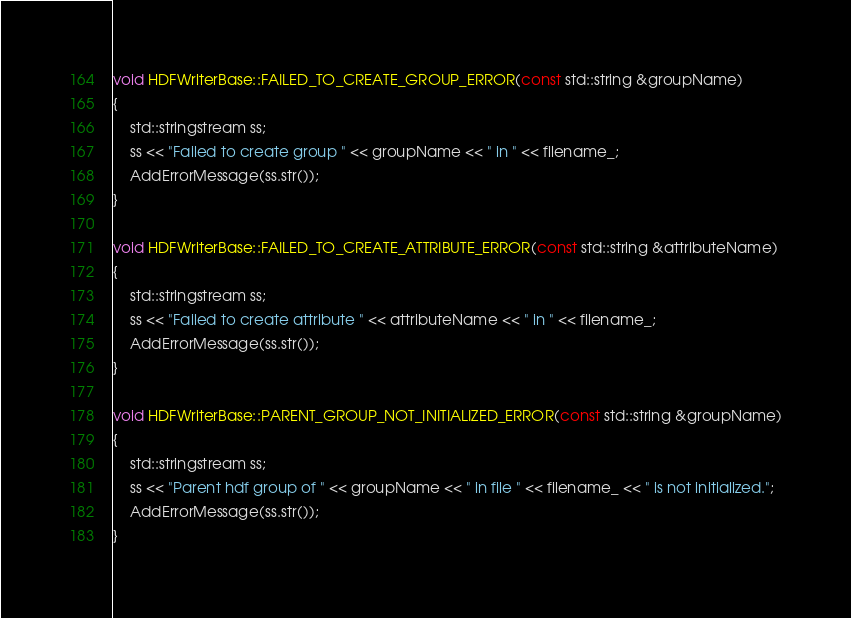Convert code to text. <code><loc_0><loc_0><loc_500><loc_500><_C++_>
void HDFWriterBase::FAILED_TO_CREATE_GROUP_ERROR(const std::string &groupName)
{
    std::stringstream ss;
    ss << "Failed to create group " << groupName << " in " << filename_;
    AddErrorMessage(ss.str());
}

void HDFWriterBase::FAILED_TO_CREATE_ATTRIBUTE_ERROR(const std::string &attributeName)
{
    std::stringstream ss;
    ss << "Failed to create attribute " << attributeName << " in " << filename_;
    AddErrorMessage(ss.str());
}

void HDFWriterBase::PARENT_GROUP_NOT_INITIALIZED_ERROR(const std::string &groupName)
{
    std::stringstream ss;
    ss << "Parent hdf group of " << groupName << " in file " << filename_ << " is not initialized.";
    AddErrorMessage(ss.str());
}
</code> 